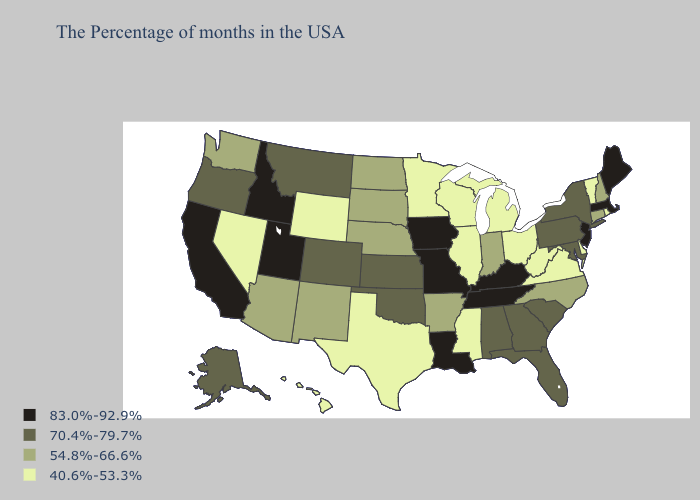Does the first symbol in the legend represent the smallest category?
Answer briefly. No. Does Illinois have a lower value than North Dakota?
Be succinct. Yes. Does Arkansas have the lowest value in the South?
Keep it brief. No. Which states have the lowest value in the South?
Answer briefly. Delaware, Virginia, West Virginia, Mississippi, Texas. What is the value of Missouri?
Write a very short answer. 83.0%-92.9%. What is the value of Utah?
Short answer required. 83.0%-92.9%. What is the highest value in the West ?
Keep it brief. 83.0%-92.9%. Among the states that border South Carolina , does North Carolina have the highest value?
Keep it brief. No. Does the first symbol in the legend represent the smallest category?
Answer briefly. No. What is the highest value in the MidWest ?
Write a very short answer. 83.0%-92.9%. Among the states that border New Jersey , which have the lowest value?
Keep it brief. Delaware. Does Colorado have a lower value than Iowa?
Give a very brief answer. Yes. Which states have the lowest value in the USA?
Short answer required. Rhode Island, Vermont, Delaware, Virginia, West Virginia, Ohio, Michigan, Wisconsin, Illinois, Mississippi, Minnesota, Texas, Wyoming, Nevada, Hawaii. Does Utah have the highest value in the West?
Write a very short answer. Yes. Name the states that have a value in the range 70.4%-79.7%?
Write a very short answer. New York, Maryland, Pennsylvania, South Carolina, Florida, Georgia, Alabama, Kansas, Oklahoma, Colorado, Montana, Oregon, Alaska. 